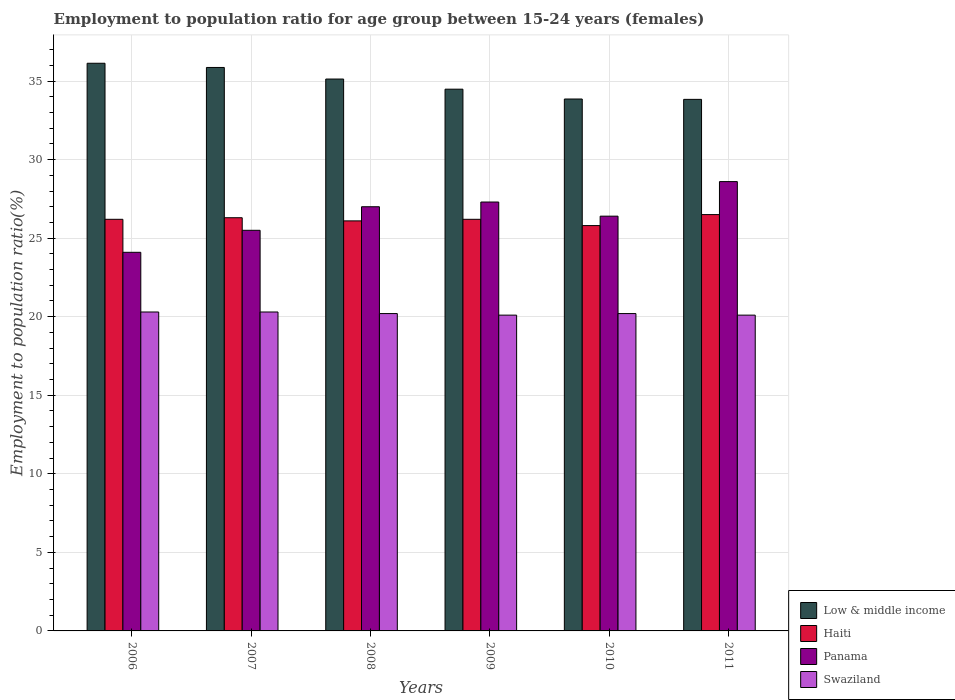How many different coloured bars are there?
Provide a succinct answer. 4. Are the number of bars on each tick of the X-axis equal?
Make the answer very short. Yes. How many bars are there on the 1st tick from the right?
Keep it short and to the point. 4. What is the employment to population ratio in Low & middle income in 2009?
Your answer should be compact. 34.48. Across all years, what is the maximum employment to population ratio in Swaziland?
Provide a succinct answer. 20.3. Across all years, what is the minimum employment to population ratio in Low & middle income?
Your answer should be very brief. 33.83. In which year was the employment to population ratio in Panama minimum?
Offer a very short reply. 2006. What is the total employment to population ratio in Swaziland in the graph?
Your answer should be compact. 121.2. What is the difference between the employment to population ratio in Low & middle income in 2009 and that in 2011?
Keep it short and to the point. 0.65. What is the difference between the employment to population ratio in Swaziland in 2008 and the employment to population ratio in Panama in 2010?
Ensure brevity in your answer.  -6.2. What is the average employment to population ratio in Swaziland per year?
Your response must be concise. 20.2. In the year 2010, what is the difference between the employment to population ratio in Swaziland and employment to population ratio in Haiti?
Keep it short and to the point. -5.6. In how many years, is the employment to population ratio in Panama greater than 32 %?
Make the answer very short. 0. What is the ratio of the employment to population ratio in Swaziland in 2006 to that in 2011?
Your answer should be compact. 1.01. What is the difference between the highest and the second highest employment to population ratio in Swaziland?
Make the answer very short. 0. What is the difference between the highest and the lowest employment to population ratio in Swaziland?
Your response must be concise. 0.2. In how many years, is the employment to population ratio in Swaziland greater than the average employment to population ratio in Swaziland taken over all years?
Provide a short and direct response. 4. Is the sum of the employment to population ratio in Haiti in 2008 and 2011 greater than the maximum employment to population ratio in Low & middle income across all years?
Provide a succinct answer. Yes. What does the 2nd bar from the left in 2007 represents?
Ensure brevity in your answer.  Haiti. What does the 2nd bar from the right in 2006 represents?
Provide a succinct answer. Panama. Is it the case that in every year, the sum of the employment to population ratio in Panama and employment to population ratio in Haiti is greater than the employment to population ratio in Swaziland?
Ensure brevity in your answer.  Yes. What is the difference between two consecutive major ticks on the Y-axis?
Ensure brevity in your answer.  5. Are the values on the major ticks of Y-axis written in scientific E-notation?
Keep it short and to the point. No. How are the legend labels stacked?
Offer a very short reply. Vertical. What is the title of the graph?
Offer a very short reply. Employment to population ratio for age group between 15-24 years (females). Does "Papua New Guinea" appear as one of the legend labels in the graph?
Provide a succinct answer. No. What is the label or title of the X-axis?
Offer a terse response. Years. What is the label or title of the Y-axis?
Offer a very short reply. Employment to population ratio(%). What is the Employment to population ratio(%) of Low & middle income in 2006?
Provide a succinct answer. 36.13. What is the Employment to population ratio(%) of Haiti in 2006?
Your answer should be very brief. 26.2. What is the Employment to population ratio(%) in Panama in 2006?
Offer a very short reply. 24.1. What is the Employment to population ratio(%) of Swaziland in 2006?
Provide a succinct answer. 20.3. What is the Employment to population ratio(%) in Low & middle income in 2007?
Provide a short and direct response. 35.87. What is the Employment to population ratio(%) in Haiti in 2007?
Make the answer very short. 26.3. What is the Employment to population ratio(%) of Swaziland in 2007?
Give a very brief answer. 20.3. What is the Employment to population ratio(%) of Low & middle income in 2008?
Provide a short and direct response. 35.13. What is the Employment to population ratio(%) of Haiti in 2008?
Your response must be concise. 26.1. What is the Employment to population ratio(%) in Panama in 2008?
Your response must be concise. 27. What is the Employment to population ratio(%) of Swaziland in 2008?
Give a very brief answer. 20.2. What is the Employment to population ratio(%) in Low & middle income in 2009?
Offer a terse response. 34.48. What is the Employment to population ratio(%) of Haiti in 2009?
Provide a succinct answer. 26.2. What is the Employment to population ratio(%) in Panama in 2009?
Offer a terse response. 27.3. What is the Employment to population ratio(%) in Swaziland in 2009?
Make the answer very short. 20.1. What is the Employment to population ratio(%) of Low & middle income in 2010?
Your answer should be very brief. 33.86. What is the Employment to population ratio(%) of Haiti in 2010?
Your answer should be very brief. 25.8. What is the Employment to population ratio(%) in Panama in 2010?
Make the answer very short. 26.4. What is the Employment to population ratio(%) of Swaziland in 2010?
Your response must be concise. 20.2. What is the Employment to population ratio(%) of Low & middle income in 2011?
Offer a very short reply. 33.83. What is the Employment to population ratio(%) in Haiti in 2011?
Make the answer very short. 26.5. What is the Employment to population ratio(%) of Panama in 2011?
Provide a short and direct response. 28.6. What is the Employment to population ratio(%) of Swaziland in 2011?
Keep it short and to the point. 20.1. Across all years, what is the maximum Employment to population ratio(%) in Low & middle income?
Make the answer very short. 36.13. Across all years, what is the maximum Employment to population ratio(%) of Haiti?
Provide a succinct answer. 26.5. Across all years, what is the maximum Employment to population ratio(%) of Panama?
Give a very brief answer. 28.6. Across all years, what is the maximum Employment to population ratio(%) of Swaziland?
Your answer should be very brief. 20.3. Across all years, what is the minimum Employment to population ratio(%) in Low & middle income?
Keep it short and to the point. 33.83. Across all years, what is the minimum Employment to population ratio(%) of Haiti?
Keep it short and to the point. 25.8. Across all years, what is the minimum Employment to population ratio(%) of Panama?
Offer a very short reply. 24.1. Across all years, what is the minimum Employment to population ratio(%) of Swaziland?
Offer a very short reply. 20.1. What is the total Employment to population ratio(%) in Low & middle income in the graph?
Offer a very short reply. 209.3. What is the total Employment to population ratio(%) in Haiti in the graph?
Your response must be concise. 157.1. What is the total Employment to population ratio(%) of Panama in the graph?
Provide a succinct answer. 158.9. What is the total Employment to population ratio(%) in Swaziland in the graph?
Your response must be concise. 121.2. What is the difference between the Employment to population ratio(%) of Low & middle income in 2006 and that in 2007?
Give a very brief answer. 0.27. What is the difference between the Employment to population ratio(%) in Haiti in 2006 and that in 2007?
Give a very brief answer. -0.1. What is the difference between the Employment to population ratio(%) of Panama in 2006 and that in 2007?
Offer a terse response. -1.4. What is the difference between the Employment to population ratio(%) in Swaziland in 2006 and that in 2007?
Offer a terse response. 0. What is the difference between the Employment to population ratio(%) in Low & middle income in 2006 and that in 2008?
Your answer should be very brief. 1. What is the difference between the Employment to population ratio(%) in Low & middle income in 2006 and that in 2009?
Offer a very short reply. 1.65. What is the difference between the Employment to population ratio(%) of Panama in 2006 and that in 2009?
Keep it short and to the point. -3.2. What is the difference between the Employment to population ratio(%) in Low & middle income in 2006 and that in 2010?
Provide a short and direct response. 2.28. What is the difference between the Employment to population ratio(%) in Haiti in 2006 and that in 2010?
Offer a very short reply. 0.4. What is the difference between the Employment to population ratio(%) in Low & middle income in 2006 and that in 2011?
Your answer should be compact. 2.3. What is the difference between the Employment to population ratio(%) in Haiti in 2006 and that in 2011?
Your response must be concise. -0.3. What is the difference between the Employment to population ratio(%) in Low & middle income in 2007 and that in 2008?
Give a very brief answer. 0.74. What is the difference between the Employment to population ratio(%) in Panama in 2007 and that in 2008?
Ensure brevity in your answer.  -1.5. What is the difference between the Employment to population ratio(%) in Swaziland in 2007 and that in 2008?
Give a very brief answer. 0.1. What is the difference between the Employment to population ratio(%) in Low & middle income in 2007 and that in 2009?
Give a very brief answer. 1.38. What is the difference between the Employment to population ratio(%) of Low & middle income in 2007 and that in 2010?
Offer a terse response. 2.01. What is the difference between the Employment to population ratio(%) of Swaziland in 2007 and that in 2010?
Your response must be concise. 0.1. What is the difference between the Employment to population ratio(%) of Low & middle income in 2007 and that in 2011?
Your answer should be very brief. 2.03. What is the difference between the Employment to population ratio(%) of Panama in 2007 and that in 2011?
Your response must be concise. -3.1. What is the difference between the Employment to population ratio(%) in Low & middle income in 2008 and that in 2009?
Your response must be concise. 0.65. What is the difference between the Employment to population ratio(%) of Panama in 2008 and that in 2009?
Ensure brevity in your answer.  -0.3. What is the difference between the Employment to population ratio(%) of Swaziland in 2008 and that in 2009?
Offer a very short reply. 0.1. What is the difference between the Employment to population ratio(%) in Low & middle income in 2008 and that in 2010?
Offer a terse response. 1.27. What is the difference between the Employment to population ratio(%) of Haiti in 2008 and that in 2010?
Make the answer very short. 0.3. What is the difference between the Employment to population ratio(%) in Panama in 2008 and that in 2010?
Your answer should be very brief. 0.6. What is the difference between the Employment to population ratio(%) of Swaziland in 2008 and that in 2010?
Provide a succinct answer. 0. What is the difference between the Employment to population ratio(%) of Low & middle income in 2008 and that in 2011?
Your answer should be very brief. 1.29. What is the difference between the Employment to population ratio(%) in Haiti in 2008 and that in 2011?
Provide a short and direct response. -0.4. What is the difference between the Employment to population ratio(%) of Swaziland in 2008 and that in 2011?
Your response must be concise. 0.1. What is the difference between the Employment to population ratio(%) of Low & middle income in 2009 and that in 2010?
Your answer should be very brief. 0.63. What is the difference between the Employment to population ratio(%) of Panama in 2009 and that in 2010?
Offer a terse response. 0.9. What is the difference between the Employment to population ratio(%) of Swaziland in 2009 and that in 2010?
Keep it short and to the point. -0.1. What is the difference between the Employment to population ratio(%) of Low & middle income in 2009 and that in 2011?
Offer a terse response. 0.65. What is the difference between the Employment to population ratio(%) in Panama in 2009 and that in 2011?
Keep it short and to the point. -1.3. What is the difference between the Employment to population ratio(%) of Low & middle income in 2010 and that in 2011?
Provide a short and direct response. 0.02. What is the difference between the Employment to population ratio(%) in Haiti in 2010 and that in 2011?
Your answer should be very brief. -0.7. What is the difference between the Employment to population ratio(%) in Swaziland in 2010 and that in 2011?
Your answer should be very brief. 0.1. What is the difference between the Employment to population ratio(%) of Low & middle income in 2006 and the Employment to population ratio(%) of Haiti in 2007?
Offer a terse response. 9.83. What is the difference between the Employment to population ratio(%) in Low & middle income in 2006 and the Employment to population ratio(%) in Panama in 2007?
Give a very brief answer. 10.63. What is the difference between the Employment to population ratio(%) in Low & middle income in 2006 and the Employment to population ratio(%) in Swaziland in 2007?
Your answer should be very brief. 15.83. What is the difference between the Employment to population ratio(%) in Panama in 2006 and the Employment to population ratio(%) in Swaziland in 2007?
Make the answer very short. 3.8. What is the difference between the Employment to population ratio(%) in Low & middle income in 2006 and the Employment to population ratio(%) in Haiti in 2008?
Provide a short and direct response. 10.03. What is the difference between the Employment to population ratio(%) of Low & middle income in 2006 and the Employment to population ratio(%) of Panama in 2008?
Provide a short and direct response. 9.13. What is the difference between the Employment to population ratio(%) in Low & middle income in 2006 and the Employment to population ratio(%) in Swaziland in 2008?
Provide a succinct answer. 15.93. What is the difference between the Employment to population ratio(%) in Haiti in 2006 and the Employment to population ratio(%) in Panama in 2008?
Offer a very short reply. -0.8. What is the difference between the Employment to population ratio(%) in Haiti in 2006 and the Employment to population ratio(%) in Swaziland in 2008?
Offer a terse response. 6. What is the difference between the Employment to population ratio(%) of Panama in 2006 and the Employment to population ratio(%) of Swaziland in 2008?
Make the answer very short. 3.9. What is the difference between the Employment to population ratio(%) in Low & middle income in 2006 and the Employment to population ratio(%) in Haiti in 2009?
Your answer should be very brief. 9.93. What is the difference between the Employment to population ratio(%) of Low & middle income in 2006 and the Employment to population ratio(%) of Panama in 2009?
Ensure brevity in your answer.  8.83. What is the difference between the Employment to population ratio(%) in Low & middle income in 2006 and the Employment to population ratio(%) in Swaziland in 2009?
Offer a very short reply. 16.03. What is the difference between the Employment to population ratio(%) of Low & middle income in 2006 and the Employment to population ratio(%) of Haiti in 2010?
Provide a short and direct response. 10.33. What is the difference between the Employment to population ratio(%) in Low & middle income in 2006 and the Employment to population ratio(%) in Panama in 2010?
Offer a terse response. 9.73. What is the difference between the Employment to population ratio(%) of Low & middle income in 2006 and the Employment to population ratio(%) of Swaziland in 2010?
Your answer should be very brief. 15.93. What is the difference between the Employment to population ratio(%) in Haiti in 2006 and the Employment to population ratio(%) in Swaziland in 2010?
Your answer should be compact. 6. What is the difference between the Employment to population ratio(%) of Panama in 2006 and the Employment to population ratio(%) of Swaziland in 2010?
Ensure brevity in your answer.  3.9. What is the difference between the Employment to population ratio(%) in Low & middle income in 2006 and the Employment to population ratio(%) in Haiti in 2011?
Make the answer very short. 9.63. What is the difference between the Employment to population ratio(%) of Low & middle income in 2006 and the Employment to population ratio(%) of Panama in 2011?
Ensure brevity in your answer.  7.53. What is the difference between the Employment to population ratio(%) of Low & middle income in 2006 and the Employment to population ratio(%) of Swaziland in 2011?
Provide a succinct answer. 16.03. What is the difference between the Employment to population ratio(%) of Low & middle income in 2007 and the Employment to population ratio(%) of Haiti in 2008?
Offer a terse response. 9.77. What is the difference between the Employment to population ratio(%) of Low & middle income in 2007 and the Employment to population ratio(%) of Panama in 2008?
Give a very brief answer. 8.87. What is the difference between the Employment to population ratio(%) in Low & middle income in 2007 and the Employment to population ratio(%) in Swaziland in 2008?
Your response must be concise. 15.67. What is the difference between the Employment to population ratio(%) of Haiti in 2007 and the Employment to population ratio(%) of Panama in 2008?
Keep it short and to the point. -0.7. What is the difference between the Employment to population ratio(%) of Low & middle income in 2007 and the Employment to population ratio(%) of Haiti in 2009?
Provide a succinct answer. 9.67. What is the difference between the Employment to population ratio(%) in Low & middle income in 2007 and the Employment to population ratio(%) in Panama in 2009?
Give a very brief answer. 8.57. What is the difference between the Employment to population ratio(%) of Low & middle income in 2007 and the Employment to population ratio(%) of Swaziland in 2009?
Your answer should be very brief. 15.77. What is the difference between the Employment to population ratio(%) in Haiti in 2007 and the Employment to population ratio(%) in Panama in 2009?
Offer a very short reply. -1. What is the difference between the Employment to population ratio(%) in Low & middle income in 2007 and the Employment to population ratio(%) in Haiti in 2010?
Your answer should be compact. 10.07. What is the difference between the Employment to population ratio(%) of Low & middle income in 2007 and the Employment to population ratio(%) of Panama in 2010?
Offer a terse response. 9.47. What is the difference between the Employment to population ratio(%) of Low & middle income in 2007 and the Employment to population ratio(%) of Swaziland in 2010?
Offer a terse response. 15.67. What is the difference between the Employment to population ratio(%) of Haiti in 2007 and the Employment to population ratio(%) of Panama in 2010?
Your answer should be very brief. -0.1. What is the difference between the Employment to population ratio(%) in Haiti in 2007 and the Employment to population ratio(%) in Swaziland in 2010?
Keep it short and to the point. 6.1. What is the difference between the Employment to population ratio(%) of Low & middle income in 2007 and the Employment to population ratio(%) of Haiti in 2011?
Provide a short and direct response. 9.37. What is the difference between the Employment to population ratio(%) in Low & middle income in 2007 and the Employment to population ratio(%) in Panama in 2011?
Ensure brevity in your answer.  7.27. What is the difference between the Employment to population ratio(%) in Low & middle income in 2007 and the Employment to population ratio(%) in Swaziland in 2011?
Offer a very short reply. 15.77. What is the difference between the Employment to population ratio(%) in Panama in 2007 and the Employment to population ratio(%) in Swaziland in 2011?
Ensure brevity in your answer.  5.4. What is the difference between the Employment to population ratio(%) in Low & middle income in 2008 and the Employment to population ratio(%) in Haiti in 2009?
Offer a terse response. 8.93. What is the difference between the Employment to population ratio(%) in Low & middle income in 2008 and the Employment to population ratio(%) in Panama in 2009?
Give a very brief answer. 7.83. What is the difference between the Employment to population ratio(%) of Low & middle income in 2008 and the Employment to population ratio(%) of Swaziland in 2009?
Ensure brevity in your answer.  15.03. What is the difference between the Employment to population ratio(%) in Panama in 2008 and the Employment to population ratio(%) in Swaziland in 2009?
Make the answer very short. 6.9. What is the difference between the Employment to population ratio(%) in Low & middle income in 2008 and the Employment to population ratio(%) in Haiti in 2010?
Provide a short and direct response. 9.33. What is the difference between the Employment to population ratio(%) in Low & middle income in 2008 and the Employment to population ratio(%) in Panama in 2010?
Give a very brief answer. 8.73. What is the difference between the Employment to population ratio(%) in Low & middle income in 2008 and the Employment to population ratio(%) in Swaziland in 2010?
Offer a terse response. 14.93. What is the difference between the Employment to population ratio(%) in Panama in 2008 and the Employment to population ratio(%) in Swaziland in 2010?
Provide a succinct answer. 6.8. What is the difference between the Employment to population ratio(%) of Low & middle income in 2008 and the Employment to population ratio(%) of Haiti in 2011?
Keep it short and to the point. 8.63. What is the difference between the Employment to population ratio(%) in Low & middle income in 2008 and the Employment to population ratio(%) in Panama in 2011?
Provide a short and direct response. 6.53. What is the difference between the Employment to population ratio(%) of Low & middle income in 2008 and the Employment to population ratio(%) of Swaziland in 2011?
Provide a succinct answer. 15.03. What is the difference between the Employment to population ratio(%) of Haiti in 2008 and the Employment to population ratio(%) of Panama in 2011?
Make the answer very short. -2.5. What is the difference between the Employment to population ratio(%) of Haiti in 2008 and the Employment to population ratio(%) of Swaziland in 2011?
Keep it short and to the point. 6. What is the difference between the Employment to population ratio(%) in Low & middle income in 2009 and the Employment to population ratio(%) in Haiti in 2010?
Make the answer very short. 8.68. What is the difference between the Employment to population ratio(%) of Low & middle income in 2009 and the Employment to population ratio(%) of Panama in 2010?
Provide a short and direct response. 8.08. What is the difference between the Employment to population ratio(%) of Low & middle income in 2009 and the Employment to population ratio(%) of Swaziland in 2010?
Offer a very short reply. 14.28. What is the difference between the Employment to population ratio(%) of Haiti in 2009 and the Employment to population ratio(%) of Swaziland in 2010?
Your answer should be compact. 6. What is the difference between the Employment to population ratio(%) in Panama in 2009 and the Employment to population ratio(%) in Swaziland in 2010?
Ensure brevity in your answer.  7.1. What is the difference between the Employment to population ratio(%) in Low & middle income in 2009 and the Employment to population ratio(%) in Haiti in 2011?
Your answer should be very brief. 7.98. What is the difference between the Employment to population ratio(%) of Low & middle income in 2009 and the Employment to population ratio(%) of Panama in 2011?
Ensure brevity in your answer.  5.88. What is the difference between the Employment to population ratio(%) in Low & middle income in 2009 and the Employment to population ratio(%) in Swaziland in 2011?
Your answer should be compact. 14.38. What is the difference between the Employment to population ratio(%) in Haiti in 2009 and the Employment to population ratio(%) in Panama in 2011?
Offer a very short reply. -2.4. What is the difference between the Employment to population ratio(%) in Low & middle income in 2010 and the Employment to population ratio(%) in Haiti in 2011?
Make the answer very short. 7.36. What is the difference between the Employment to population ratio(%) in Low & middle income in 2010 and the Employment to population ratio(%) in Panama in 2011?
Your answer should be compact. 5.26. What is the difference between the Employment to population ratio(%) in Low & middle income in 2010 and the Employment to population ratio(%) in Swaziland in 2011?
Make the answer very short. 13.76. What is the difference between the Employment to population ratio(%) in Panama in 2010 and the Employment to population ratio(%) in Swaziland in 2011?
Your response must be concise. 6.3. What is the average Employment to population ratio(%) in Low & middle income per year?
Provide a succinct answer. 34.88. What is the average Employment to population ratio(%) in Haiti per year?
Your answer should be very brief. 26.18. What is the average Employment to population ratio(%) of Panama per year?
Your response must be concise. 26.48. What is the average Employment to population ratio(%) of Swaziland per year?
Offer a terse response. 20.2. In the year 2006, what is the difference between the Employment to population ratio(%) of Low & middle income and Employment to population ratio(%) of Haiti?
Ensure brevity in your answer.  9.93. In the year 2006, what is the difference between the Employment to population ratio(%) in Low & middle income and Employment to population ratio(%) in Panama?
Keep it short and to the point. 12.03. In the year 2006, what is the difference between the Employment to population ratio(%) in Low & middle income and Employment to population ratio(%) in Swaziland?
Make the answer very short. 15.83. In the year 2007, what is the difference between the Employment to population ratio(%) of Low & middle income and Employment to population ratio(%) of Haiti?
Your response must be concise. 9.57. In the year 2007, what is the difference between the Employment to population ratio(%) of Low & middle income and Employment to population ratio(%) of Panama?
Ensure brevity in your answer.  10.37. In the year 2007, what is the difference between the Employment to population ratio(%) in Low & middle income and Employment to population ratio(%) in Swaziland?
Your response must be concise. 15.57. In the year 2007, what is the difference between the Employment to population ratio(%) in Haiti and Employment to population ratio(%) in Panama?
Ensure brevity in your answer.  0.8. In the year 2007, what is the difference between the Employment to population ratio(%) of Panama and Employment to population ratio(%) of Swaziland?
Give a very brief answer. 5.2. In the year 2008, what is the difference between the Employment to population ratio(%) of Low & middle income and Employment to population ratio(%) of Haiti?
Keep it short and to the point. 9.03. In the year 2008, what is the difference between the Employment to population ratio(%) of Low & middle income and Employment to population ratio(%) of Panama?
Offer a very short reply. 8.13. In the year 2008, what is the difference between the Employment to population ratio(%) in Low & middle income and Employment to population ratio(%) in Swaziland?
Keep it short and to the point. 14.93. In the year 2008, what is the difference between the Employment to population ratio(%) of Haiti and Employment to population ratio(%) of Panama?
Make the answer very short. -0.9. In the year 2009, what is the difference between the Employment to population ratio(%) in Low & middle income and Employment to population ratio(%) in Haiti?
Your response must be concise. 8.28. In the year 2009, what is the difference between the Employment to population ratio(%) in Low & middle income and Employment to population ratio(%) in Panama?
Keep it short and to the point. 7.18. In the year 2009, what is the difference between the Employment to population ratio(%) in Low & middle income and Employment to population ratio(%) in Swaziland?
Provide a short and direct response. 14.38. In the year 2010, what is the difference between the Employment to population ratio(%) of Low & middle income and Employment to population ratio(%) of Haiti?
Your answer should be compact. 8.06. In the year 2010, what is the difference between the Employment to population ratio(%) of Low & middle income and Employment to population ratio(%) of Panama?
Provide a short and direct response. 7.46. In the year 2010, what is the difference between the Employment to population ratio(%) in Low & middle income and Employment to population ratio(%) in Swaziland?
Offer a terse response. 13.66. In the year 2010, what is the difference between the Employment to population ratio(%) of Haiti and Employment to population ratio(%) of Panama?
Your response must be concise. -0.6. In the year 2010, what is the difference between the Employment to population ratio(%) of Haiti and Employment to population ratio(%) of Swaziland?
Provide a succinct answer. 5.6. In the year 2010, what is the difference between the Employment to population ratio(%) in Panama and Employment to population ratio(%) in Swaziland?
Make the answer very short. 6.2. In the year 2011, what is the difference between the Employment to population ratio(%) in Low & middle income and Employment to population ratio(%) in Haiti?
Offer a very short reply. 7.33. In the year 2011, what is the difference between the Employment to population ratio(%) in Low & middle income and Employment to population ratio(%) in Panama?
Make the answer very short. 5.23. In the year 2011, what is the difference between the Employment to population ratio(%) of Low & middle income and Employment to population ratio(%) of Swaziland?
Give a very brief answer. 13.73. In the year 2011, what is the difference between the Employment to population ratio(%) in Haiti and Employment to population ratio(%) in Panama?
Make the answer very short. -2.1. What is the ratio of the Employment to population ratio(%) in Low & middle income in 2006 to that in 2007?
Offer a terse response. 1.01. What is the ratio of the Employment to population ratio(%) in Haiti in 2006 to that in 2007?
Your response must be concise. 1. What is the ratio of the Employment to population ratio(%) of Panama in 2006 to that in 2007?
Provide a succinct answer. 0.95. What is the ratio of the Employment to population ratio(%) of Low & middle income in 2006 to that in 2008?
Offer a very short reply. 1.03. What is the ratio of the Employment to population ratio(%) of Haiti in 2006 to that in 2008?
Ensure brevity in your answer.  1. What is the ratio of the Employment to population ratio(%) of Panama in 2006 to that in 2008?
Keep it short and to the point. 0.89. What is the ratio of the Employment to population ratio(%) in Swaziland in 2006 to that in 2008?
Make the answer very short. 1. What is the ratio of the Employment to population ratio(%) in Low & middle income in 2006 to that in 2009?
Your answer should be very brief. 1.05. What is the ratio of the Employment to population ratio(%) of Panama in 2006 to that in 2009?
Offer a very short reply. 0.88. What is the ratio of the Employment to population ratio(%) of Low & middle income in 2006 to that in 2010?
Your answer should be compact. 1.07. What is the ratio of the Employment to population ratio(%) in Haiti in 2006 to that in 2010?
Provide a succinct answer. 1.02. What is the ratio of the Employment to population ratio(%) of Panama in 2006 to that in 2010?
Make the answer very short. 0.91. What is the ratio of the Employment to population ratio(%) in Swaziland in 2006 to that in 2010?
Ensure brevity in your answer.  1. What is the ratio of the Employment to population ratio(%) in Low & middle income in 2006 to that in 2011?
Make the answer very short. 1.07. What is the ratio of the Employment to population ratio(%) of Haiti in 2006 to that in 2011?
Offer a very short reply. 0.99. What is the ratio of the Employment to population ratio(%) of Panama in 2006 to that in 2011?
Provide a succinct answer. 0.84. What is the ratio of the Employment to population ratio(%) in Swaziland in 2006 to that in 2011?
Give a very brief answer. 1.01. What is the ratio of the Employment to population ratio(%) in Haiti in 2007 to that in 2008?
Keep it short and to the point. 1.01. What is the ratio of the Employment to population ratio(%) of Swaziland in 2007 to that in 2008?
Your answer should be compact. 1. What is the ratio of the Employment to population ratio(%) of Low & middle income in 2007 to that in 2009?
Your answer should be compact. 1.04. What is the ratio of the Employment to population ratio(%) of Haiti in 2007 to that in 2009?
Your answer should be very brief. 1. What is the ratio of the Employment to population ratio(%) in Panama in 2007 to that in 2009?
Provide a short and direct response. 0.93. What is the ratio of the Employment to population ratio(%) of Swaziland in 2007 to that in 2009?
Give a very brief answer. 1.01. What is the ratio of the Employment to population ratio(%) of Low & middle income in 2007 to that in 2010?
Provide a short and direct response. 1.06. What is the ratio of the Employment to population ratio(%) of Haiti in 2007 to that in 2010?
Make the answer very short. 1.02. What is the ratio of the Employment to population ratio(%) in Panama in 2007 to that in 2010?
Make the answer very short. 0.97. What is the ratio of the Employment to population ratio(%) of Swaziland in 2007 to that in 2010?
Your response must be concise. 1. What is the ratio of the Employment to population ratio(%) in Low & middle income in 2007 to that in 2011?
Ensure brevity in your answer.  1.06. What is the ratio of the Employment to population ratio(%) of Panama in 2007 to that in 2011?
Make the answer very short. 0.89. What is the ratio of the Employment to population ratio(%) of Low & middle income in 2008 to that in 2009?
Your response must be concise. 1.02. What is the ratio of the Employment to population ratio(%) of Haiti in 2008 to that in 2009?
Provide a short and direct response. 1. What is the ratio of the Employment to population ratio(%) of Panama in 2008 to that in 2009?
Offer a terse response. 0.99. What is the ratio of the Employment to population ratio(%) in Low & middle income in 2008 to that in 2010?
Offer a very short reply. 1.04. What is the ratio of the Employment to population ratio(%) of Haiti in 2008 to that in 2010?
Offer a terse response. 1.01. What is the ratio of the Employment to population ratio(%) in Panama in 2008 to that in 2010?
Offer a very short reply. 1.02. What is the ratio of the Employment to population ratio(%) of Low & middle income in 2008 to that in 2011?
Ensure brevity in your answer.  1.04. What is the ratio of the Employment to population ratio(%) in Haiti in 2008 to that in 2011?
Your response must be concise. 0.98. What is the ratio of the Employment to population ratio(%) of Panama in 2008 to that in 2011?
Offer a very short reply. 0.94. What is the ratio of the Employment to population ratio(%) of Swaziland in 2008 to that in 2011?
Provide a succinct answer. 1. What is the ratio of the Employment to population ratio(%) in Low & middle income in 2009 to that in 2010?
Offer a terse response. 1.02. What is the ratio of the Employment to population ratio(%) in Haiti in 2009 to that in 2010?
Give a very brief answer. 1.02. What is the ratio of the Employment to population ratio(%) in Panama in 2009 to that in 2010?
Your answer should be very brief. 1.03. What is the ratio of the Employment to population ratio(%) in Swaziland in 2009 to that in 2010?
Your response must be concise. 0.99. What is the ratio of the Employment to population ratio(%) of Low & middle income in 2009 to that in 2011?
Your answer should be compact. 1.02. What is the ratio of the Employment to population ratio(%) in Haiti in 2009 to that in 2011?
Provide a succinct answer. 0.99. What is the ratio of the Employment to population ratio(%) in Panama in 2009 to that in 2011?
Give a very brief answer. 0.95. What is the ratio of the Employment to population ratio(%) of Low & middle income in 2010 to that in 2011?
Ensure brevity in your answer.  1. What is the ratio of the Employment to population ratio(%) of Haiti in 2010 to that in 2011?
Provide a succinct answer. 0.97. What is the ratio of the Employment to population ratio(%) of Panama in 2010 to that in 2011?
Offer a terse response. 0.92. What is the ratio of the Employment to population ratio(%) of Swaziland in 2010 to that in 2011?
Offer a very short reply. 1. What is the difference between the highest and the second highest Employment to population ratio(%) of Low & middle income?
Offer a very short reply. 0.27. What is the difference between the highest and the second highest Employment to population ratio(%) in Swaziland?
Your answer should be compact. 0. What is the difference between the highest and the lowest Employment to population ratio(%) of Low & middle income?
Offer a very short reply. 2.3. What is the difference between the highest and the lowest Employment to population ratio(%) of Haiti?
Offer a terse response. 0.7. What is the difference between the highest and the lowest Employment to population ratio(%) of Panama?
Ensure brevity in your answer.  4.5. 